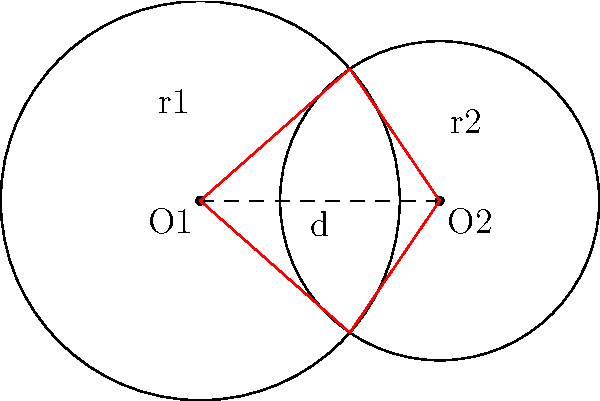In an autonomous vehicle system, two circular sensor ranges overlap. Sensor 1 has a range of 2.5 units, centered at O1(0,0), and Sensor 2 has a range of 2 units, centered at O2(3,0). Calculate the area of the overlapping region between these two sensor ranges. To calculate the area of overlap between two circles, we can use the following steps:

1. Calculate the distance (d) between the centers:
   $d = 3$ (given in the diagram)

2. Check if there's an overlap:
   $r_1 + r_2 > d$ (2.5 + 2 > 3), so there is an overlap.

3. Calculate the central angles ($\theta_1$ and $\theta_2$) using the law of cosines:
   $\cos(\frac{\theta_1}{2}) = \frac{r_1^2 + d^2 - r_2^2}{2r_1d}$
   $\cos(\frac{\theta_2}{2}) = \frac{r_2^2 + d^2 - r_1^2}{2r_2d}$

   $\theta_1 = 2 \arccos(\frac{2.5^2 + 3^2 - 2^2}{2 * 2.5 * 3}) \approx 1.8395$ radians
   $\theta_2 = 2 \arccos(\frac{2^2 + 3^2 - 2.5^2}{2 * 2 * 3}) \approx 2.4863$ radians

4. Calculate the areas of the circular sectors:
   $A_1 = \frac{1}{2}r_1^2\theta_1 \approx 5.7484$
   $A_2 = \frac{1}{2}r_2^2\theta_2 \approx 4.9726$

5. Calculate the area of the triangle formed by the centers and an intersection point:
   $A_t = \frac{1}{2}r_1r_2\sin(\frac{\theta_1}{2})\sin(\frac{\theta_2}{2}) \approx 2.3512$

6. Calculate the overlap area:
   $A_{overlap} = A_1 + A_2 - 2A_t \approx 6.0186$

Therefore, the area of the overlapping region is approximately 6.0186 square units.
Answer: 6.0186 square units 